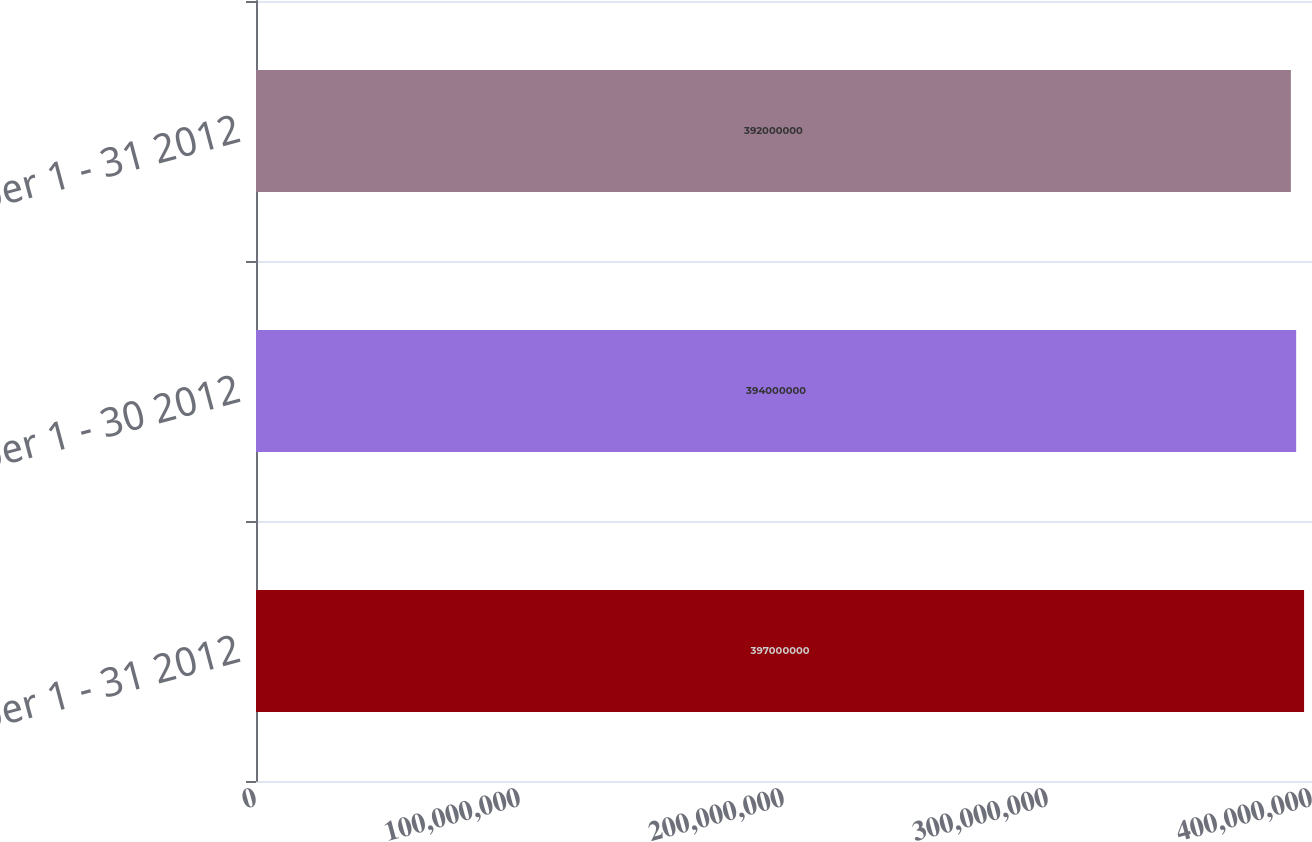Convert chart. <chart><loc_0><loc_0><loc_500><loc_500><bar_chart><fcel>October 1 - 31 2012<fcel>November 1 - 30 2012<fcel>December 1 - 31 2012<nl><fcel>3.97e+08<fcel>3.94e+08<fcel>3.92e+08<nl></chart> 